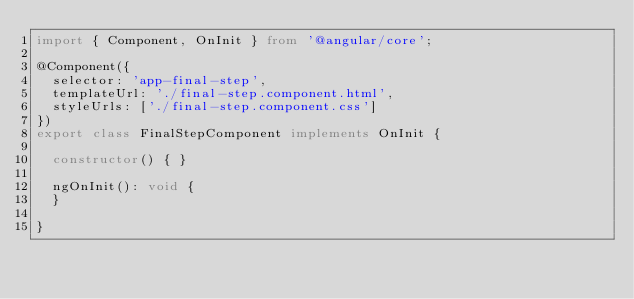<code> <loc_0><loc_0><loc_500><loc_500><_TypeScript_>import { Component, OnInit } from '@angular/core';

@Component({
  selector: 'app-final-step',
  templateUrl: './final-step.component.html',
  styleUrls: ['./final-step.component.css']
})
export class FinalStepComponent implements OnInit {

  constructor() { }

  ngOnInit(): void {
  }

}
</code> 